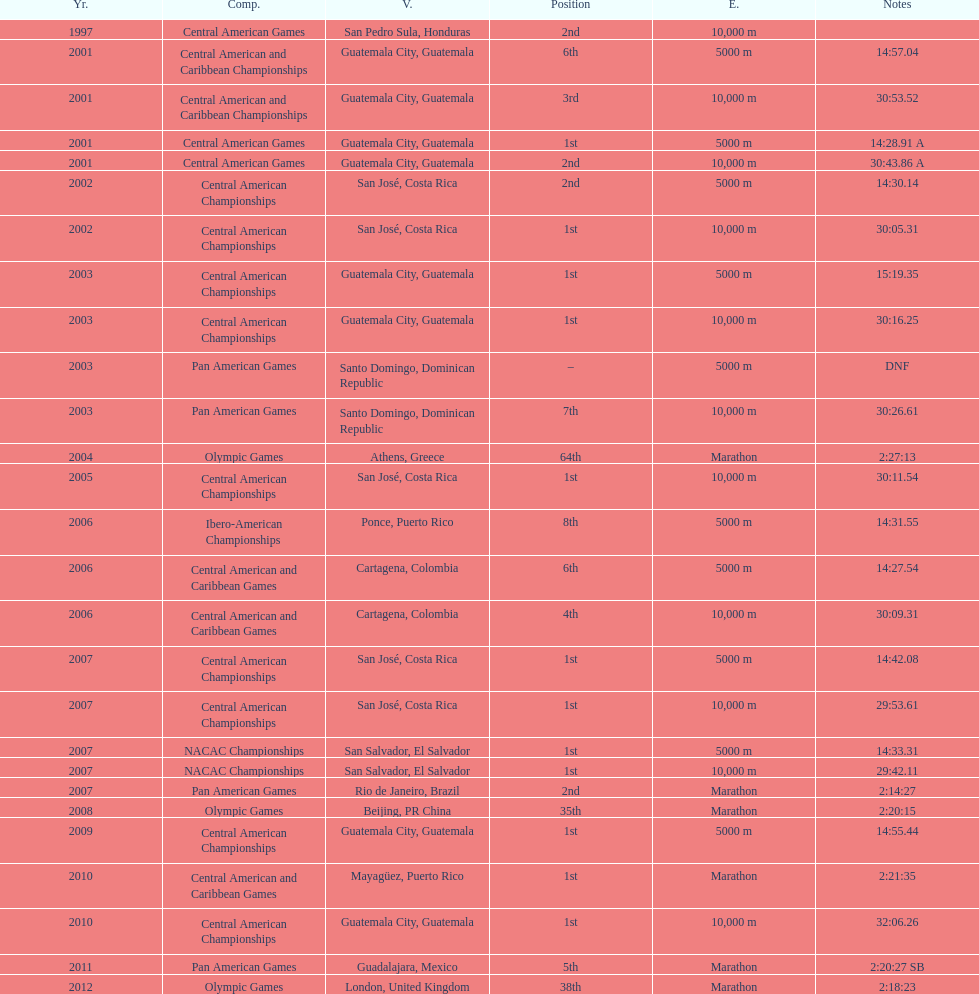The central american championships and which other event took place in 2010? Central American and Caribbean Games. 